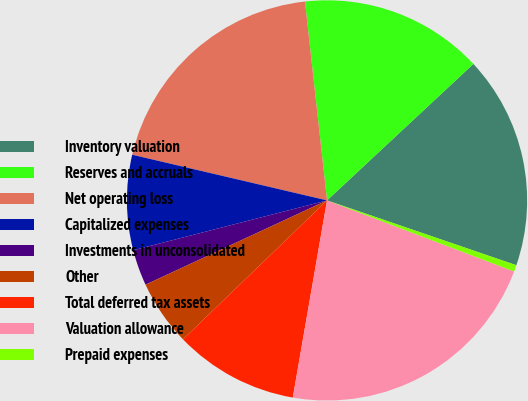<chart> <loc_0><loc_0><loc_500><loc_500><pie_chart><fcel>Inventory valuation<fcel>Reserves and accruals<fcel>Net operating loss<fcel>Capitalized expenses<fcel>Investments in unconsolidated<fcel>Other<fcel>Total deferred tax assets<fcel>Valuation allowance<fcel>Prepaid expenses<nl><fcel>17.19%<fcel>14.81%<fcel>19.57%<fcel>7.67%<fcel>2.91%<fcel>5.29%<fcel>10.05%<fcel>21.95%<fcel>0.53%<nl></chart> 